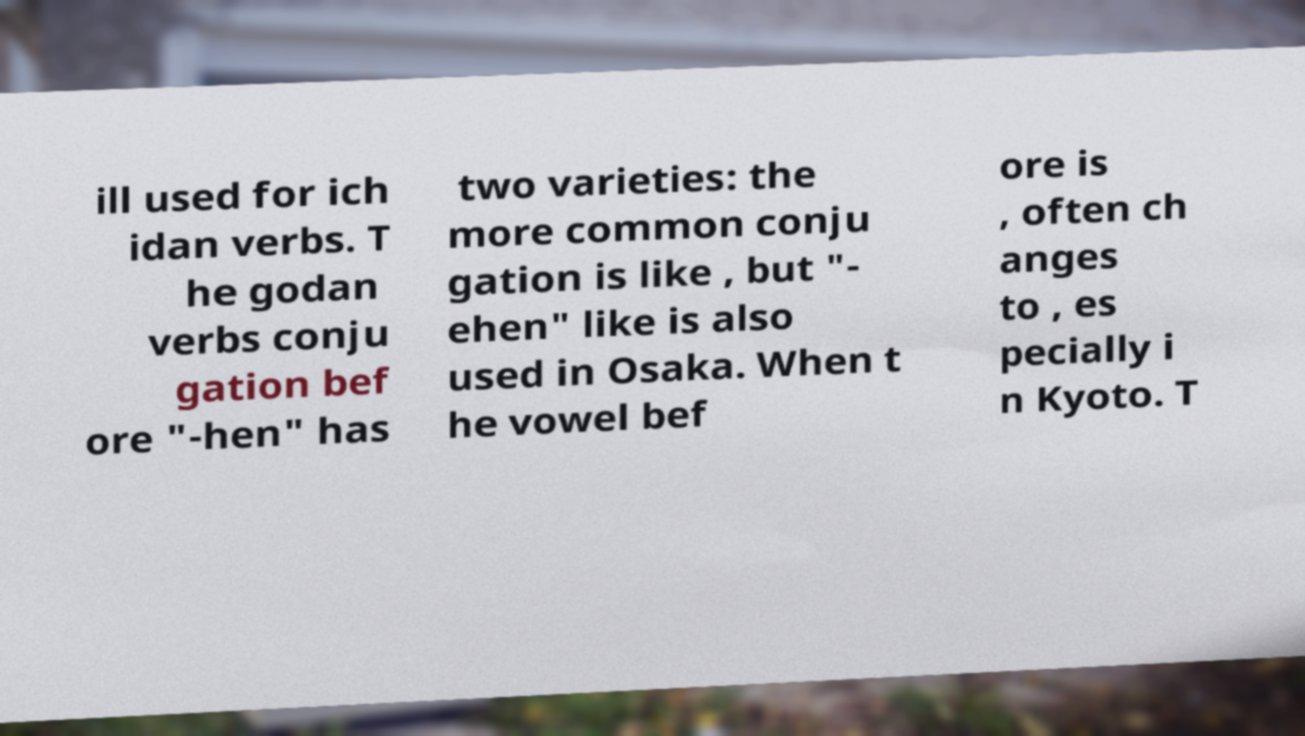I need the written content from this picture converted into text. Can you do that? ill used for ich idan verbs. T he godan verbs conju gation bef ore "-hen" has two varieties: the more common conju gation is like , but "- ehen" like is also used in Osaka. When t he vowel bef ore is , often ch anges to , es pecially i n Kyoto. T 